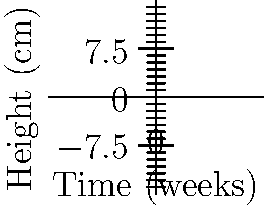You are studying the growth patterns of three newly discovered plant species. The graph shows their growth curves over 8 weeks. Which species exhibits the fastest growth rate at the 6-week mark, and what type of polynomial function best describes its growth pattern? To determine the fastest growth rate at the 6-week mark and identify the polynomial function, we need to analyze each curve:

1. Observe the slopes of each curve at x = 6 (6-week mark). The steepest slope indicates the fastest growth rate.

2. Species A (blue): Appears to be a quadratic function ($ax^2 + bx + c$). Its slope is increasing steadily.

3. Species B (red): Resembles a cubic function ($ax^3 + bx^2 + cx + d$). Its growth rate is decreasing at x = 6.

4. Species C (green): Also appears to be a cubic function. It has the steepest slope at x = 6, indicating the fastest growth rate.

5. To confirm, we could calculate the derivative of each function at x = 6, but visually, Species C clearly has the steepest slope.

6. The growth pattern of Species C is best described by a cubic polynomial function due to its S-shaped curve with an inflection point.
Answer: Species C; cubic polynomial function 